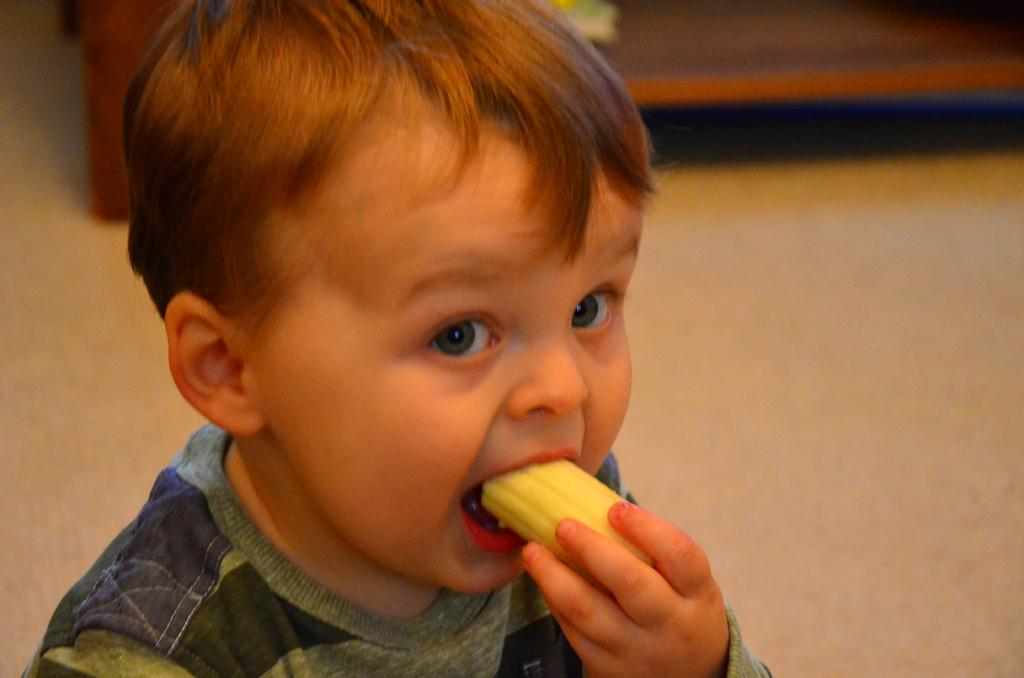What is the main subject of the image? The main subject of the image is a small child. What is the child doing in the image? The child is eating a piece of banana. What can be seen in the background of the image? There is a blurred floor in the background of the image. What is the temperature of the balls in the image? There are no balls present in the image, so it is not possible to determine their temperature. 